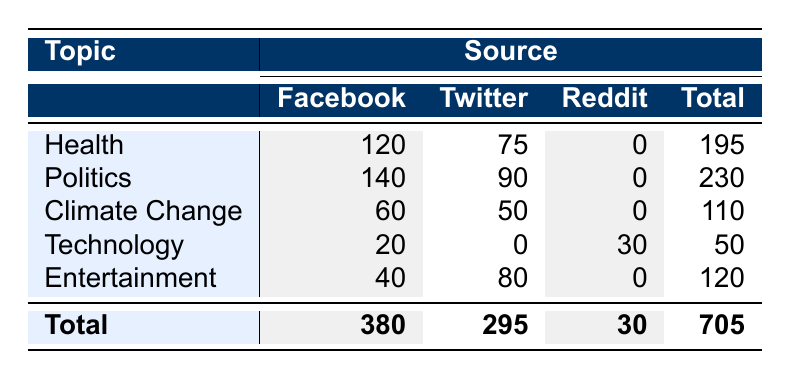What topic has the highest total misinformation identified? To find the topic with the highest total misinformation, we need to look at the "Total" column in the table. The totals for each topic are Health (195), Politics (230), Climate Change (110), Technology (50), and Entertainment (120). The highest total is 230 for Politics.
Answer: Politics How much misinformation was identified on Facebook for the Health topic? Looking at the row for the Health topic, the value under the Facebook column is 120.
Answer: 120 What is the total amount of misinformation identified across all sources? To find the total misinformation across all sources, we can refer to the "Total" column at the bottom of the table. The total amount is 705.
Answer: 705 How much more misinformation was identified in Politics on Facebook compared to Twitter? For the Politics topic, the misinformation identified on Facebook is 140, and on Twitter, it is 90. The difference is 140 - 90 = 50.
Answer: 50 Is the amount of misinformation about Climate Change greater than that for Technology? The total misinformation for Climate Change is 110, while for Technology, it is 50. Since 110 is greater than 50, this statement is true.
Answer: Yes What is the average amount of misinformation identified across all sources for the Entertainment topic? The total misinformation for Entertainment is 120. Since there are two sources (Facebook and Twitter), we calculate the average by dividing 120 by 2, which gives us 60.
Answer: 60 Which source had the least total misinformation identified? To find out which source had the least total misinformation, we need to look at the sums for each source: Facebook (380), Twitter (295), Reddit (30). The source with the least identified misinformation is Reddit with 30.
Answer: Reddit What percentage of the total misinformation is identified from Twitter? The total misinformation identified from Twitter is 295, while the overall total is 705. We find the percentage by (295 / 705) * 100 ≈ 41.9%.
Answer: 41.9% What is the difference in misinformation identified for Health and Entertainment? For Health, the total is 195, and for Entertainment, it is 120. The difference is 195 - 120 = 75.
Answer: 75 